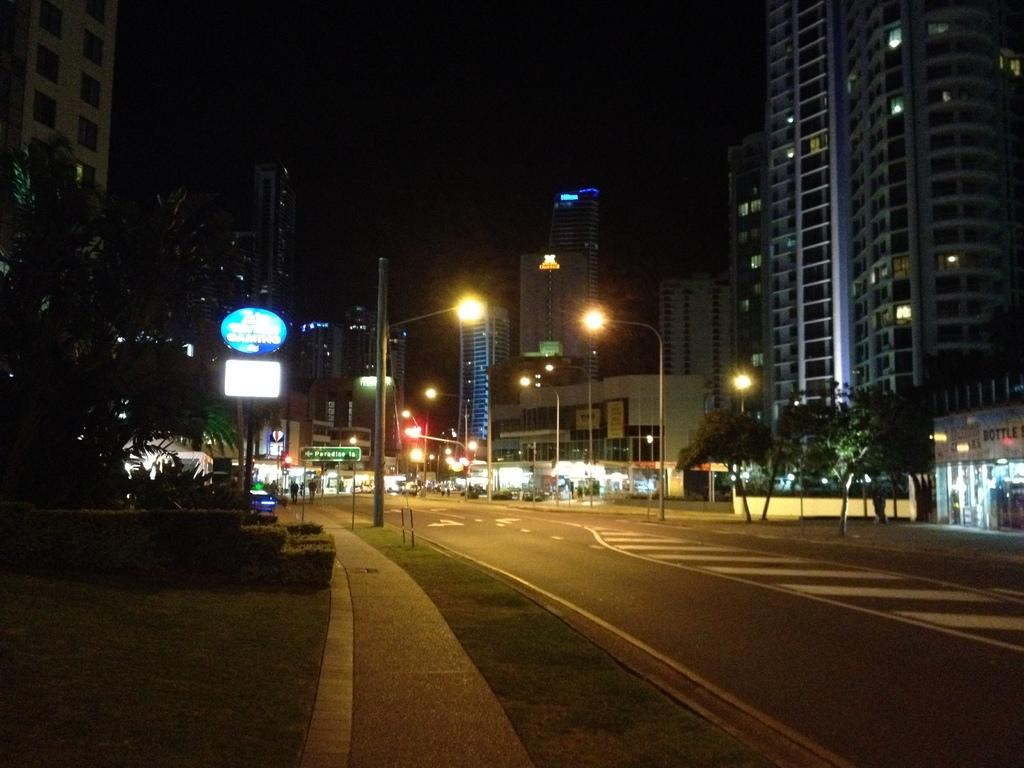What type of structures can be seen in the image? There are buildings in the image. What are the light sources in the image? There are light poles in the image. What type of vegetation is present in the image? There are trees in the image. What type of information is displayed in the image? There are boards with text and signs in the image. How would you describe the overall lighting in the image? The background of the image is dark. What type of milk is being heated in the oven in the image? There is no oven or milk present in the image. How many beans are visible on the tree in the image? There are no beans or trees with beans in the image. 